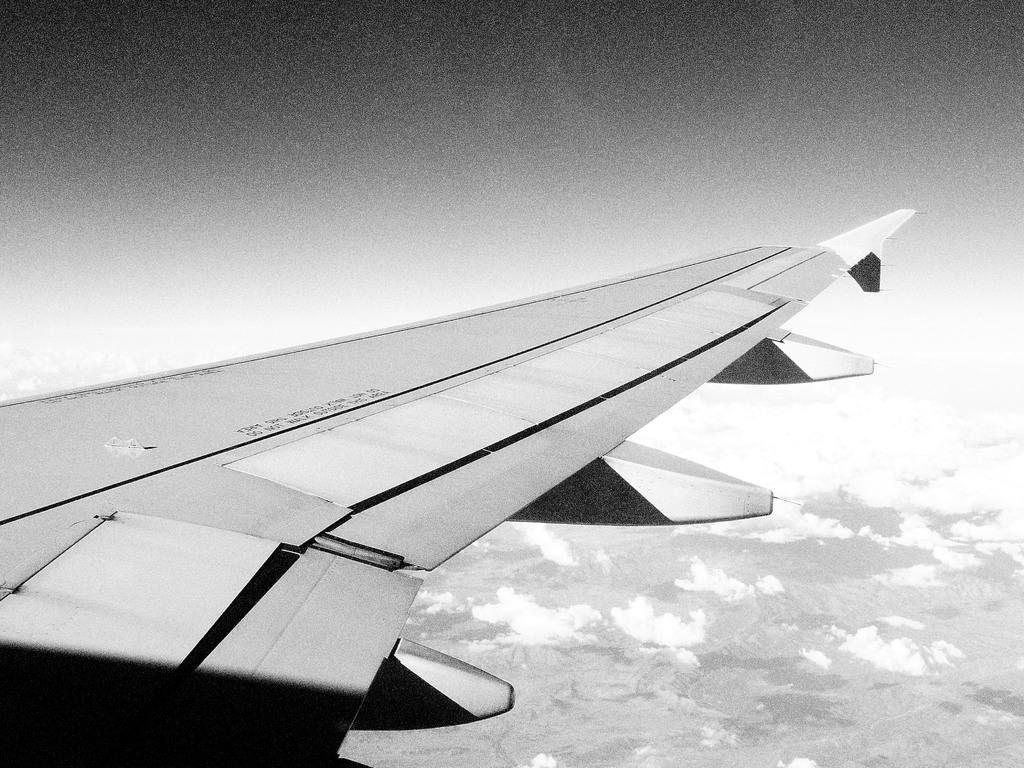What is the main subject of the picture? The main subject of the picture is an airplane wing. What can be seen in the background of the picture? There are mountains and clouds visible in the background of the picture. What type of chin can be seen on the airplane wing in the image? There is no chin present on the airplane wing in the image, as it is a part of an aircraft and not a living being. 